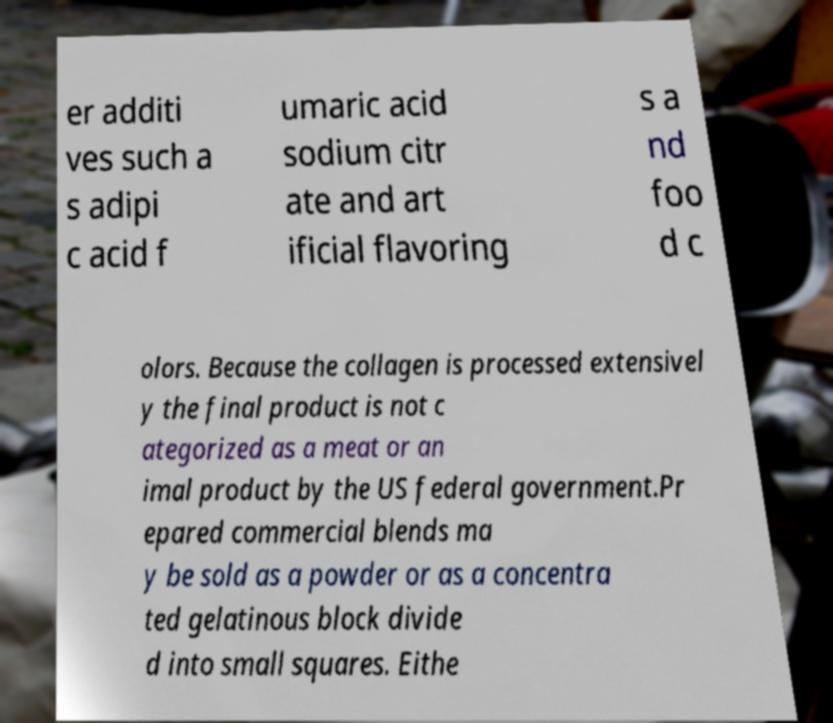Can you accurately transcribe the text from the provided image for me? er additi ves such a s adipi c acid f umaric acid sodium citr ate and art ificial flavoring s a nd foo d c olors. Because the collagen is processed extensivel y the final product is not c ategorized as a meat or an imal product by the US federal government.Pr epared commercial blends ma y be sold as a powder or as a concentra ted gelatinous block divide d into small squares. Eithe 